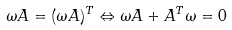<formula> <loc_0><loc_0><loc_500><loc_500>\omega A = ( \omega A ) ^ { T } \Leftrightarrow \omega A + A ^ { T } \omega = 0</formula> 